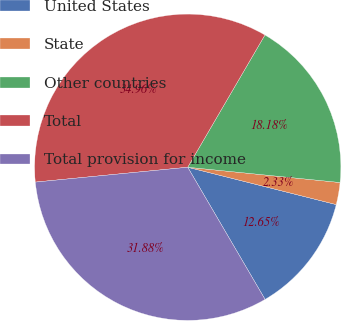<chart> <loc_0><loc_0><loc_500><loc_500><pie_chart><fcel>United States<fcel>State<fcel>Other countries<fcel>Total<fcel>Total provision for income<nl><fcel>12.65%<fcel>2.33%<fcel>18.18%<fcel>34.96%<fcel>31.88%<nl></chart> 